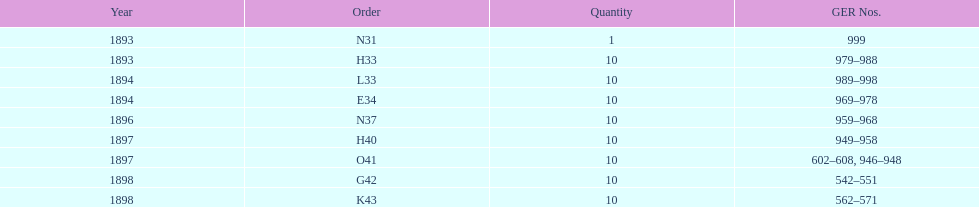What was the subsequent order following l33? E34. 